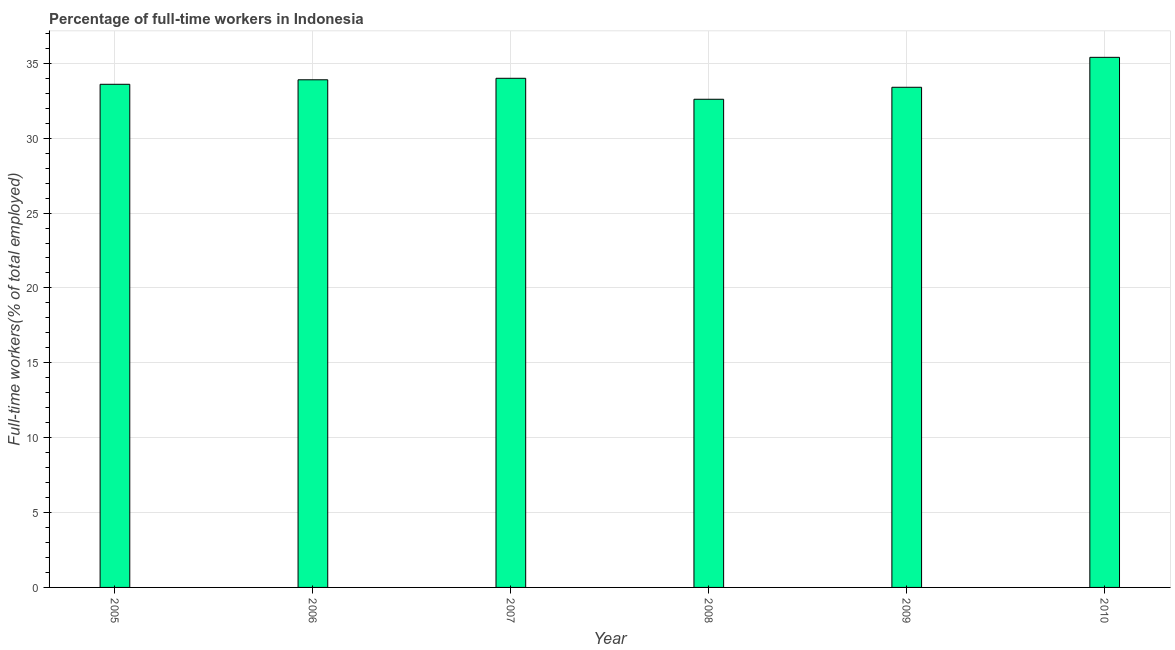What is the title of the graph?
Give a very brief answer. Percentage of full-time workers in Indonesia. What is the label or title of the Y-axis?
Ensure brevity in your answer.  Full-time workers(% of total employed). What is the percentage of full-time workers in 2005?
Your response must be concise. 33.6. Across all years, what is the maximum percentage of full-time workers?
Keep it short and to the point. 35.4. Across all years, what is the minimum percentage of full-time workers?
Provide a succinct answer. 32.6. What is the sum of the percentage of full-time workers?
Your response must be concise. 202.9. What is the average percentage of full-time workers per year?
Give a very brief answer. 33.82. What is the median percentage of full-time workers?
Provide a short and direct response. 33.75. Do a majority of the years between 2009 and 2010 (inclusive) have percentage of full-time workers greater than 27 %?
Your answer should be very brief. Yes. Is the percentage of full-time workers in 2007 less than that in 2008?
Give a very brief answer. No. Is the difference between the percentage of full-time workers in 2005 and 2006 greater than the difference between any two years?
Offer a terse response. No. What is the difference between the highest and the second highest percentage of full-time workers?
Give a very brief answer. 1.4. Is the sum of the percentage of full-time workers in 2006 and 2010 greater than the maximum percentage of full-time workers across all years?
Keep it short and to the point. Yes. In how many years, is the percentage of full-time workers greater than the average percentage of full-time workers taken over all years?
Offer a terse response. 3. How many years are there in the graph?
Ensure brevity in your answer.  6. What is the difference between two consecutive major ticks on the Y-axis?
Provide a short and direct response. 5. Are the values on the major ticks of Y-axis written in scientific E-notation?
Give a very brief answer. No. What is the Full-time workers(% of total employed) in 2005?
Your answer should be compact. 33.6. What is the Full-time workers(% of total employed) in 2006?
Your answer should be compact. 33.9. What is the Full-time workers(% of total employed) of 2008?
Your response must be concise. 32.6. What is the Full-time workers(% of total employed) in 2009?
Make the answer very short. 33.4. What is the Full-time workers(% of total employed) in 2010?
Ensure brevity in your answer.  35.4. What is the difference between the Full-time workers(% of total employed) in 2005 and 2007?
Your answer should be compact. -0.4. What is the difference between the Full-time workers(% of total employed) in 2006 and 2008?
Ensure brevity in your answer.  1.3. What is the difference between the Full-time workers(% of total employed) in 2006 and 2009?
Give a very brief answer. 0.5. What is the difference between the Full-time workers(% of total employed) in 2006 and 2010?
Your response must be concise. -1.5. What is the difference between the Full-time workers(% of total employed) in 2008 and 2009?
Give a very brief answer. -0.8. What is the difference between the Full-time workers(% of total employed) in 2009 and 2010?
Your answer should be compact. -2. What is the ratio of the Full-time workers(% of total employed) in 2005 to that in 2006?
Keep it short and to the point. 0.99. What is the ratio of the Full-time workers(% of total employed) in 2005 to that in 2008?
Make the answer very short. 1.03. What is the ratio of the Full-time workers(% of total employed) in 2005 to that in 2009?
Ensure brevity in your answer.  1.01. What is the ratio of the Full-time workers(% of total employed) in 2005 to that in 2010?
Ensure brevity in your answer.  0.95. What is the ratio of the Full-time workers(% of total employed) in 2006 to that in 2007?
Make the answer very short. 1. What is the ratio of the Full-time workers(% of total employed) in 2006 to that in 2008?
Your answer should be very brief. 1.04. What is the ratio of the Full-time workers(% of total employed) in 2006 to that in 2009?
Provide a short and direct response. 1.01. What is the ratio of the Full-time workers(% of total employed) in 2006 to that in 2010?
Provide a short and direct response. 0.96. What is the ratio of the Full-time workers(% of total employed) in 2007 to that in 2008?
Offer a very short reply. 1.04. What is the ratio of the Full-time workers(% of total employed) in 2007 to that in 2010?
Give a very brief answer. 0.96. What is the ratio of the Full-time workers(% of total employed) in 2008 to that in 2009?
Offer a terse response. 0.98. What is the ratio of the Full-time workers(% of total employed) in 2008 to that in 2010?
Make the answer very short. 0.92. What is the ratio of the Full-time workers(% of total employed) in 2009 to that in 2010?
Ensure brevity in your answer.  0.94. 